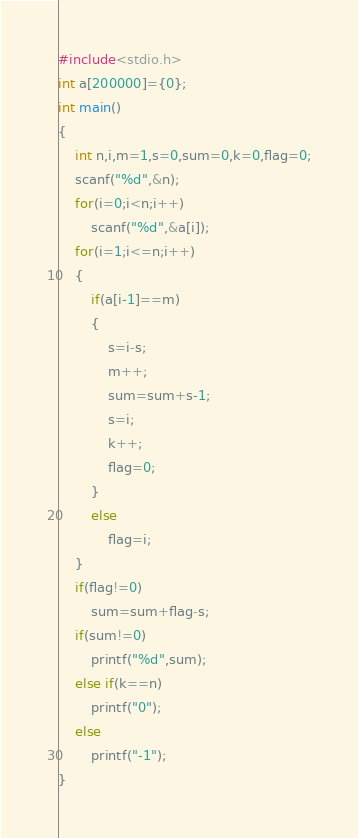Convert code to text. <code><loc_0><loc_0><loc_500><loc_500><_C++_>#include<stdio.h>
int a[200000]={0};
int main()
{
	int n,i,m=1,s=0,sum=0,k=0,flag=0;
	scanf("%d",&n);
	for(i=0;i<n;i++)
		scanf("%d",&a[i]);
	for(i=1;i<=n;i++)
	{
		if(a[i-1]==m)
		{
			s=i-s;
			m++;
			sum=sum+s-1;
			s=i;
			k++;
			flag=0;
		}
		else 
			flag=i;
	}
	if(flag!=0)
		sum=sum+flag-s;
	if(sum!=0)
		printf("%d",sum);
	else if(k==n)
		printf("0");
	else 
		printf("-1");
}</code> 